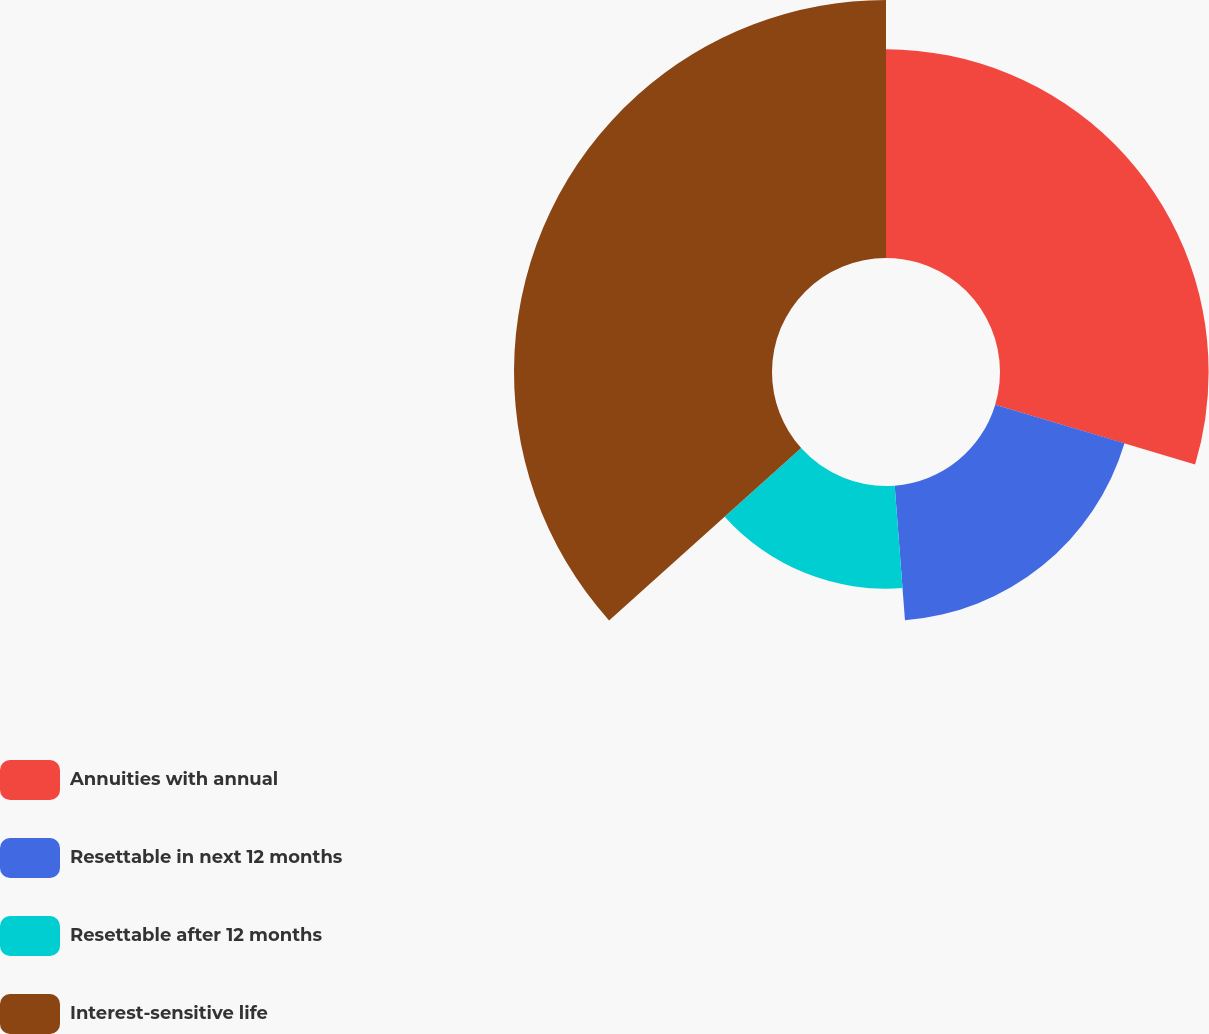<chart> <loc_0><loc_0><loc_500><loc_500><pie_chart><fcel>Annuities with annual<fcel>Resettable in next 12 months<fcel>Resettable after 12 months<fcel>Interest-sensitive life<nl><fcel>29.63%<fcel>19.16%<fcel>14.58%<fcel>36.64%<nl></chart> 